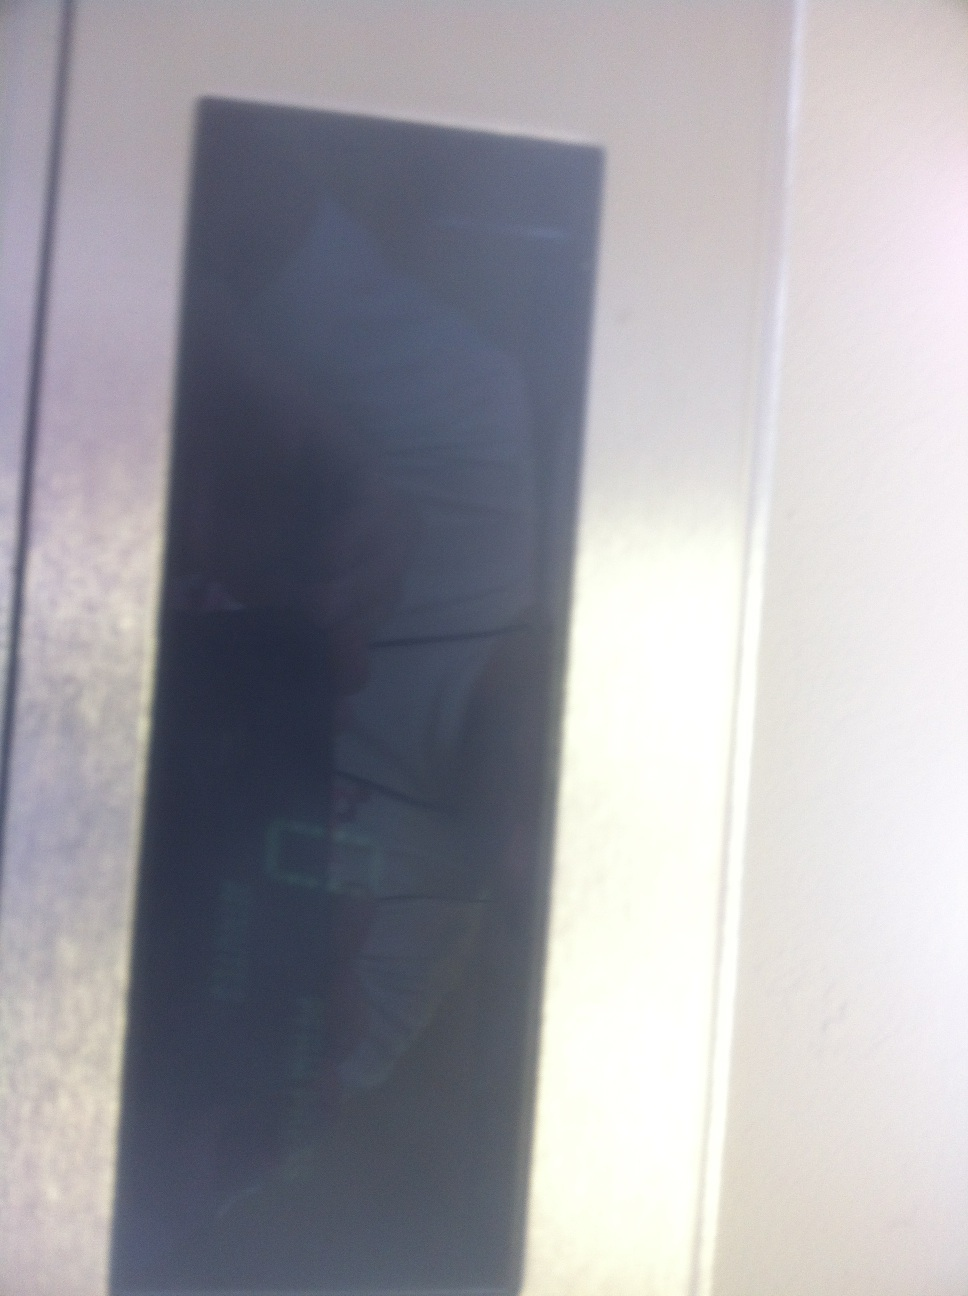Describe a quick glance scenario using this display in daily life. In daily life, a quick glance at this display might occur when you enter your office building. It could be part of an electronic check-in system, showing your work schedule as you badge in, or displaying a welcome message along with the current date and time. This brief interaction helps you stay informed and ready for the day's tasks. 